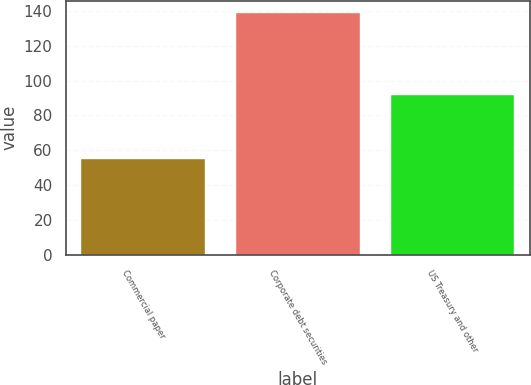<chart> <loc_0><loc_0><loc_500><loc_500><bar_chart><fcel>Commercial paper<fcel>Corporate debt securities<fcel>US Treasury and other<nl><fcel>55<fcel>139<fcel>92<nl></chart> 